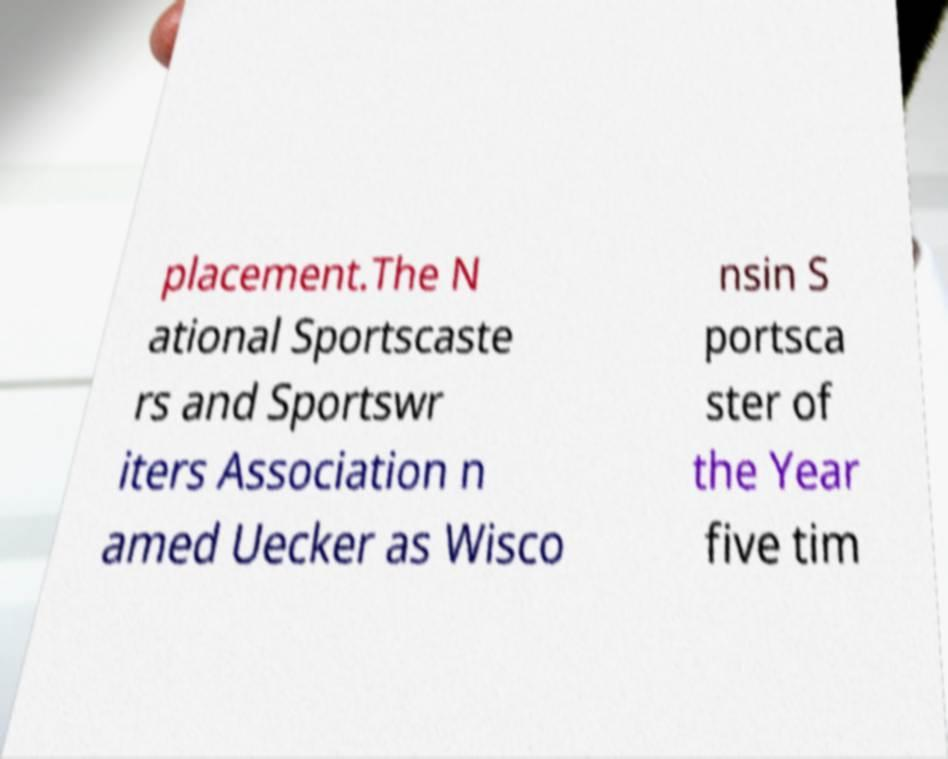Can you read and provide the text displayed in the image?This photo seems to have some interesting text. Can you extract and type it out for me? placement.The N ational Sportscaste rs and Sportswr iters Association n amed Uecker as Wisco nsin S portsca ster of the Year five tim 